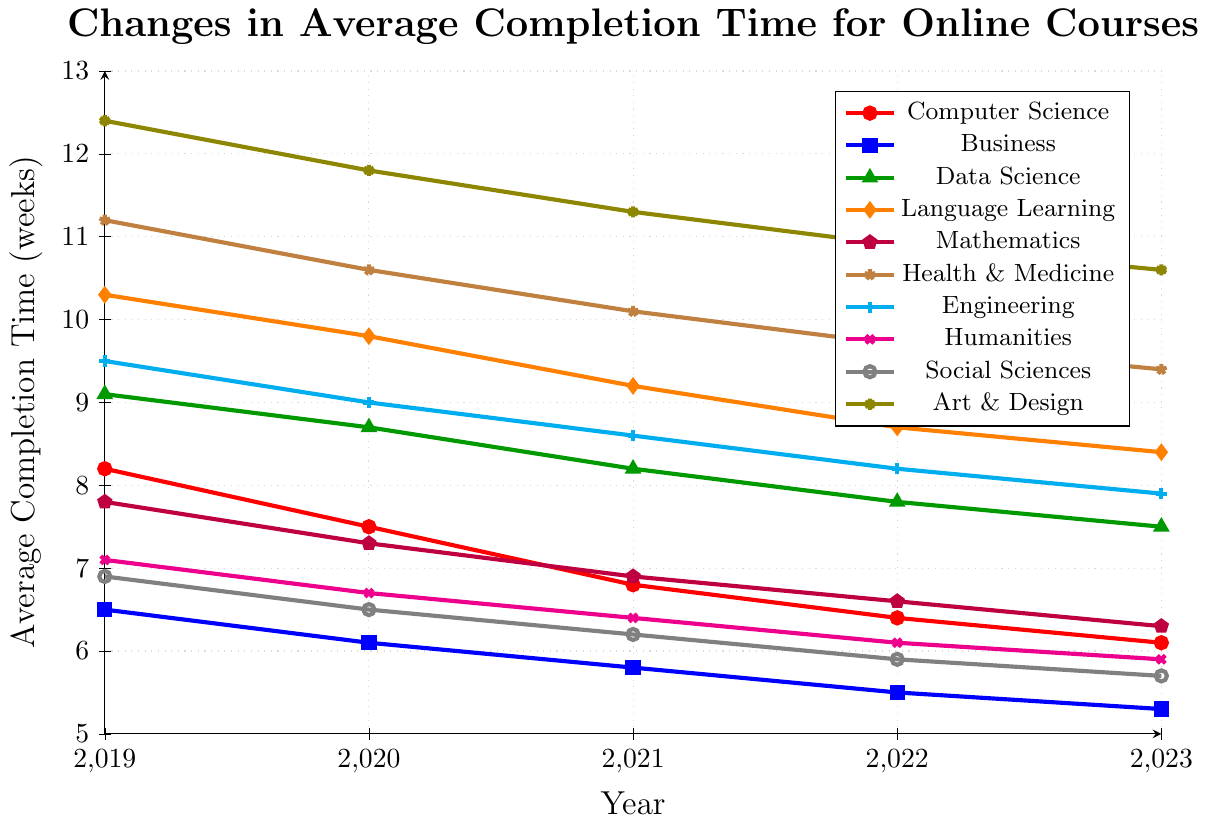What subject had the highest average completion time in 2023? By looking at the y-values in 2023, it's clear that Art & Design has the highest value, which is 10.6
Answer: Art & Design Which subject experienced the most significant decrease in average completion time from 2019 to 2023? We calculate the differences for each subject from 2019 to 2023: Computer Science (8.2 - 6.1 = 2.1), Business (6.5 - 5.3 = 1.2), Data Science (9.1 - 7.5 = 1.6), Language Learning (10.3 - 8.4 = 1.9), Mathematics (7.8 - 6.3 = 1.5), Health & Medicine (11.2 - 9.4 = 1.8), Engineering (9.5 - 7.9 = 1.6), Humanities (7.1 - 5.9 = 1.2), Social Sciences (6.9 - 5.7 = 1.2), Art & Design (12.4 - 10.6 = 1.8). The results show that Computer Science had the most significant decrease (2.1).
Answer: Computer Science In 2021, which subject had a higher average completion time: Mathematics or Social Sciences? By comparing the y-values for Mathematics (6.9) and Social Sciences (6.2) in 2021, Mathematics had the higher value.
Answer: Mathematics What was the trend in average completion time for Data Science from 2019 to 2023? By observing the coordinates for Data Science (9.1, 8.7, 8.2, 7.8, 7.5), there is a consistent decrease in average completion time over the years.
Answer: Decreasing What was the average completion time for Humanities in 2020 and 2023? The y-values for Humanities in 2020 and 2023 are 6.7 and 5.9, respectively. The average is calculated by (6.7 + 5.9) / 2 = 6.3
Answer: 6.3 Which two subjects showed the smallest overall reduction in average completion time from 2019 to 2023? By calculating the differences: Computer Science (2.1), Business (1.2), Data Science (1.6), Language Learning (1.9), Mathematics (1.5), Health & Medicine (1.8), Engineering (1.6), Humanities (1.2), Social Sciences (1.2), Art & Design (1.8). The smallest differences are in Business, Humanities, and Social Sciences (all 1.2).
Answer: Business, Humanities, Social Sciences (tied) Which subject area had a lower average completion time in 2021: Health & Medicine or Art & Design? By comparing their y-values in 2021, Health & Medicine had 10.1 and Art & Design had 11.3. So, Health & Medicine had a lower time.
Answer: Health & Medicine How did the average completion time for Engineering change between 2020 and 2023? The y-values for Engineering in 2020 and 2023 are 9.0 and 7.9, respectively. The change is calculated by 9.0 - 7.9 = 1.1 decrease.
Answer: Decreased by 1.1 Between which consecutive years did Business see the smallest change in average completion time? By calculating the year-to-year changes: 2019-2020 (6.5 - 6.1 = 0.4), 2020-2021 (6.1 - 5.8 = 0.3), 2021-2022 (5.8 - 5.5 = 0.3), and 2022-2023 (5.5 - 5.3 = 0.2). The smallest change was between 2022-2023.
Answer: 2022 and 2023 